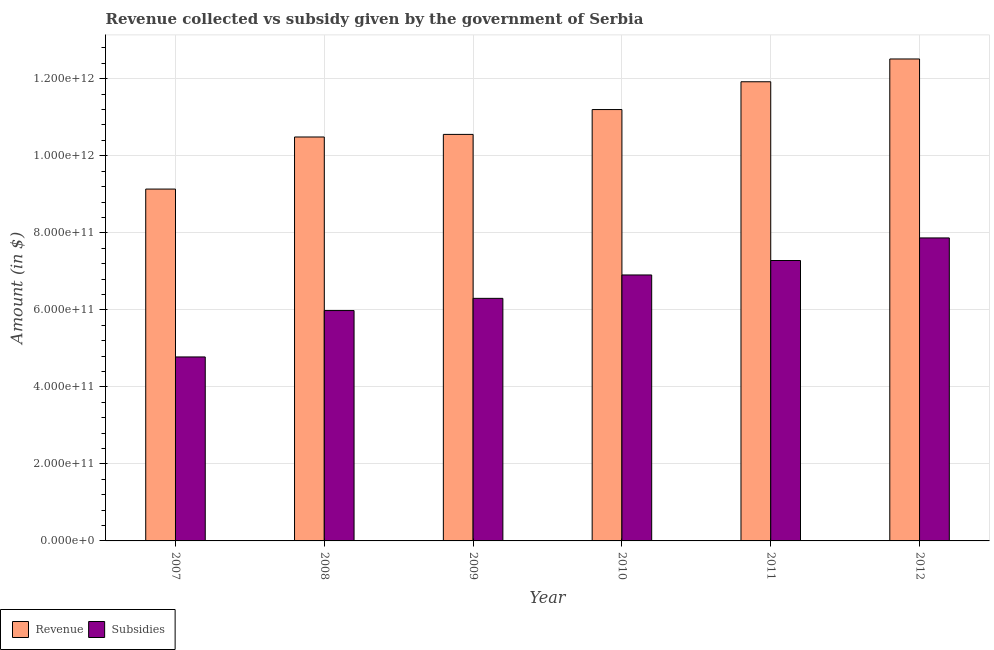How many different coloured bars are there?
Give a very brief answer. 2. How many groups of bars are there?
Your answer should be compact. 6. Are the number of bars per tick equal to the number of legend labels?
Offer a terse response. Yes. How many bars are there on the 2nd tick from the left?
Make the answer very short. 2. What is the label of the 4th group of bars from the left?
Give a very brief answer. 2010. What is the amount of subsidies given in 2007?
Your answer should be very brief. 4.78e+11. Across all years, what is the maximum amount of revenue collected?
Provide a succinct answer. 1.25e+12. Across all years, what is the minimum amount of subsidies given?
Keep it short and to the point. 4.78e+11. In which year was the amount of subsidies given minimum?
Offer a terse response. 2007. What is the total amount of subsidies given in the graph?
Give a very brief answer. 3.91e+12. What is the difference between the amount of revenue collected in 2008 and that in 2011?
Your answer should be very brief. -1.43e+11. What is the difference between the amount of revenue collected in 2008 and the amount of subsidies given in 2010?
Keep it short and to the point. -7.13e+1. What is the average amount of subsidies given per year?
Your response must be concise. 6.52e+11. In how many years, is the amount of subsidies given greater than 800000000000 $?
Offer a terse response. 0. What is the ratio of the amount of revenue collected in 2007 to that in 2009?
Offer a terse response. 0.87. Is the amount of revenue collected in 2007 less than that in 2008?
Offer a very short reply. Yes. Is the difference between the amount of revenue collected in 2010 and 2011 greater than the difference between the amount of subsidies given in 2010 and 2011?
Give a very brief answer. No. What is the difference between the highest and the second highest amount of revenue collected?
Make the answer very short. 5.92e+1. What is the difference between the highest and the lowest amount of revenue collected?
Make the answer very short. 3.38e+11. Is the sum of the amount of revenue collected in 2011 and 2012 greater than the maximum amount of subsidies given across all years?
Offer a terse response. Yes. What does the 1st bar from the left in 2008 represents?
Ensure brevity in your answer.  Revenue. What does the 1st bar from the right in 2008 represents?
Ensure brevity in your answer.  Subsidies. Are all the bars in the graph horizontal?
Give a very brief answer. No. What is the difference between two consecutive major ticks on the Y-axis?
Make the answer very short. 2.00e+11. Are the values on the major ticks of Y-axis written in scientific E-notation?
Provide a short and direct response. Yes. Does the graph contain any zero values?
Keep it short and to the point. No. Where does the legend appear in the graph?
Give a very brief answer. Bottom left. How many legend labels are there?
Make the answer very short. 2. How are the legend labels stacked?
Your answer should be very brief. Horizontal. What is the title of the graph?
Provide a succinct answer. Revenue collected vs subsidy given by the government of Serbia. What is the label or title of the X-axis?
Give a very brief answer. Year. What is the label or title of the Y-axis?
Provide a succinct answer. Amount (in $). What is the Amount (in $) in Revenue in 2007?
Offer a terse response. 9.14e+11. What is the Amount (in $) of Subsidies in 2007?
Make the answer very short. 4.78e+11. What is the Amount (in $) in Revenue in 2008?
Your response must be concise. 1.05e+12. What is the Amount (in $) of Subsidies in 2008?
Your answer should be very brief. 5.98e+11. What is the Amount (in $) of Revenue in 2009?
Offer a terse response. 1.06e+12. What is the Amount (in $) of Subsidies in 2009?
Offer a very short reply. 6.30e+11. What is the Amount (in $) of Revenue in 2010?
Your answer should be very brief. 1.12e+12. What is the Amount (in $) in Subsidies in 2010?
Your response must be concise. 6.91e+11. What is the Amount (in $) of Revenue in 2011?
Your answer should be compact. 1.19e+12. What is the Amount (in $) of Subsidies in 2011?
Your answer should be very brief. 7.28e+11. What is the Amount (in $) of Revenue in 2012?
Your response must be concise. 1.25e+12. What is the Amount (in $) of Subsidies in 2012?
Your response must be concise. 7.87e+11. Across all years, what is the maximum Amount (in $) of Revenue?
Your response must be concise. 1.25e+12. Across all years, what is the maximum Amount (in $) in Subsidies?
Your answer should be compact. 7.87e+11. Across all years, what is the minimum Amount (in $) in Revenue?
Your response must be concise. 9.14e+11. Across all years, what is the minimum Amount (in $) of Subsidies?
Your response must be concise. 4.78e+11. What is the total Amount (in $) of Revenue in the graph?
Provide a succinct answer. 6.58e+12. What is the total Amount (in $) in Subsidies in the graph?
Offer a very short reply. 3.91e+12. What is the difference between the Amount (in $) of Revenue in 2007 and that in 2008?
Ensure brevity in your answer.  -1.35e+11. What is the difference between the Amount (in $) of Subsidies in 2007 and that in 2008?
Ensure brevity in your answer.  -1.20e+11. What is the difference between the Amount (in $) in Revenue in 2007 and that in 2009?
Keep it short and to the point. -1.42e+11. What is the difference between the Amount (in $) in Subsidies in 2007 and that in 2009?
Make the answer very short. -1.52e+11. What is the difference between the Amount (in $) in Revenue in 2007 and that in 2010?
Give a very brief answer. -2.06e+11. What is the difference between the Amount (in $) in Subsidies in 2007 and that in 2010?
Offer a terse response. -2.13e+11. What is the difference between the Amount (in $) in Revenue in 2007 and that in 2011?
Provide a short and direct response. -2.79e+11. What is the difference between the Amount (in $) of Subsidies in 2007 and that in 2011?
Your answer should be compact. -2.50e+11. What is the difference between the Amount (in $) in Revenue in 2007 and that in 2012?
Offer a terse response. -3.38e+11. What is the difference between the Amount (in $) of Subsidies in 2007 and that in 2012?
Offer a very short reply. -3.09e+11. What is the difference between the Amount (in $) of Revenue in 2008 and that in 2009?
Make the answer very short. -6.74e+09. What is the difference between the Amount (in $) of Subsidies in 2008 and that in 2009?
Your response must be concise. -3.17e+1. What is the difference between the Amount (in $) of Revenue in 2008 and that in 2010?
Your answer should be compact. -7.13e+1. What is the difference between the Amount (in $) in Subsidies in 2008 and that in 2010?
Your answer should be compact. -9.24e+1. What is the difference between the Amount (in $) of Revenue in 2008 and that in 2011?
Provide a short and direct response. -1.43e+11. What is the difference between the Amount (in $) in Subsidies in 2008 and that in 2011?
Your answer should be very brief. -1.30e+11. What is the difference between the Amount (in $) of Revenue in 2008 and that in 2012?
Make the answer very short. -2.03e+11. What is the difference between the Amount (in $) of Subsidies in 2008 and that in 2012?
Keep it short and to the point. -1.89e+11. What is the difference between the Amount (in $) in Revenue in 2009 and that in 2010?
Your answer should be very brief. -6.45e+1. What is the difference between the Amount (in $) in Subsidies in 2009 and that in 2010?
Ensure brevity in your answer.  -6.07e+1. What is the difference between the Amount (in $) of Revenue in 2009 and that in 2011?
Make the answer very short. -1.37e+11. What is the difference between the Amount (in $) of Subsidies in 2009 and that in 2011?
Offer a terse response. -9.83e+1. What is the difference between the Amount (in $) of Revenue in 2009 and that in 2012?
Offer a terse response. -1.96e+11. What is the difference between the Amount (in $) in Subsidies in 2009 and that in 2012?
Your answer should be compact. -1.57e+11. What is the difference between the Amount (in $) in Revenue in 2010 and that in 2011?
Your response must be concise. -7.22e+1. What is the difference between the Amount (in $) of Subsidies in 2010 and that in 2011?
Ensure brevity in your answer.  -3.75e+1. What is the difference between the Amount (in $) of Revenue in 2010 and that in 2012?
Provide a short and direct response. -1.31e+11. What is the difference between the Amount (in $) in Subsidies in 2010 and that in 2012?
Your answer should be compact. -9.62e+1. What is the difference between the Amount (in $) of Revenue in 2011 and that in 2012?
Your answer should be compact. -5.92e+1. What is the difference between the Amount (in $) of Subsidies in 2011 and that in 2012?
Your response must be concise. -5.86e+1. What is the difference between the Amount (in $) of Revenue in 2007 and the Amount (in $) of Subsidies in 2008?
Provide a succinct answer. 3.15e+11. What is the difference between the Amount (in $) in Revenue in 2007 and the Amount (in $) in Subsidies in 2009?
Offer a terse response. 2.84e+11. What is the difference between the Amount (in $) of Revenue in 2007 and the Amount (in $) of Subsidies in 2010?
Offer a very short reply. 2.23e+11. What is the difference between the Amount (in $) in Revenue in 2007 and the Amount (in $) in Subsidies in 2011?
Ensure brevity in your answer.  1.86e+11. What is the difference between the Amount (in $) of Revenue in 2007 and the Amount (in $) of Subsidies in 2012?
Provide a succinct answer. 1.27e+11. What is the difference between the Amount (in $) in Revenue in 2008 and the Amount (in $) in Subsidies in 2009?
Offer a very short reply. 4.19e+11. What is the difference between the Amount (in $) in Revenue in 2008 and the Amount (in $) in Subsidies in 2010?
Make the answer very short. 3.58e+11. What is the difference between the Amount (in $) of Revenue in 2008 and the Amount (in $) of Subsidies in 2011?
Your response must be concise. 3.21e+11. What is the difference between the Amount (in $) in Revenue in 2008 and the Amount (in $) in Subsidies in 2012?
Provide a succinct answer. 2.62e+11. What is the difference between the Amount (in $) of Revenue in 2009 and the Amount (in $) of Subsidies in 2010?
Keep it short and to the point. 3.65e+11. What is the difference between the Amount (in $) in Revenue in 2009 and the Amount (in $) in Subsidies in 2011?
Give a very brief answer. 3.27e+11. What is the difference between the Amount (in $) in Revenue in 2009 and the Amount (in $) in Subsidies in 2012?
Your answer should be compact. 2.69e+11. What is the difference between the Amount (in $) of Revenue in 2010 and the Amount (in $) of Subsidies in 2011?
Keep it short and to the point. 3.92e+11. What is the difference between the Amount (in $) of Revenue in 2010 and the Amount (in $) of Subsidies in 2012?
Offer a terse response. 3.33e+11. What is the difference between the Amount (in $) in Revenue in 2011 and the Amount (in $) in Subsidies in 2012?
Give a very brief answer. 4.06e+11. What is the average Amount (in $) of Revenue per year?
Provide a short and direct response. 1.10e+12. What is the average Amount (in $) of Subsidies per year?
Your response must be concise. 6.52e+11. In the year 2007, what is the difference between the Amount (in $) in Revenue and Amount (in $) in Subsidies?
Offer a very short reply. 4.36e+11. In the year 2008, what is the difference between the Amount (in $) of Revenue and Amount (in $) of Subsidies?
Offer a terse response. 4.51e+11. In the year 2009, what is the difference between the Amount (in $) in Revenue and Amount (in $) in Subsidies?
Give a very brief answer. 4.26e+11. In the year 2010, what is the difference between the Amount (in $) in Revenue and Amount (in $) in Subsidies?
Offer a terse response. 4.29e+11. In the year 2011, what is the difference between the Amount (in $) in Revenue and Amount (in $) in Subsidies?
Provide a short and direct response. 4.64e+11. In the year 2012, what is the difference between the Amount (in $) in Revenue and Amount (in $) in Subsidies?
Provide a succinct answer. 4.65e+11. What is the ratio of the Amount (in $) of Revenue in 2007 to that in 2008?
Provide a short and direct response. 0.87. What is the ratio of the Amount (in $) of Subsidies in 2007 to that in 2008?
Keep it short and to the point. 0.8. What is the ratio of the Amount (in $) in Revenue in 2007 to that in 2009?
Offer a terse response. 0.87. What is the ratio of the Amount (in $) of Subsidies in 2007 to that in 2009?
Offer a terse response. 0.76. What is the ratio of the Amount (in $) of Revenue in 2007 to that in 2010?
Your answer should be compact. 0.82. What is the ratio of the Amount (in $) of Subsidies in 2007 to that in 2010?
Keep it short and to the point. 0.69. What is the ratio of the Amount (in $) of Revenue in 2007 to that in 2011?
Your answer should be very brief. 0.77. What is the ratio of the Amount (in $) in Subsidies in 2007 to that in 2011?
Give a very brief answer. 0.66. What is the ratio of the Amount (in $) of Revenue in 2007 to that in 2012?
Offer a very short reply. 0.73. What is the ratio of the Amount (in $) in Subsidies in 2007 to that in 2012?
Give a very brief answer. 0.61. What is the ratio of the Amount (in $) in Revenue in 2008 to that in 2009?
Your answer should be very brief. 0.99. What is the ratio of the Amount (in $) in Subsidies in 2008 to that in 2009?
Provide a succinct answer. 0.95. What is the ratio of the Amount (in $) of Revenue in 2008 to that in 2010?
Provide a short and direct response. 0.94. What is the ratio of the Amount (in $) in Subsidies in 2008 to that in 2010?
Provide a short and direct response. 0.87. What is the ratio of the Amount (in $) in Revenue in 2008 to that in 2011?
Provide a succinct answer. 0.88. What is the ratio of the Amount (in $) in Subsidies in 2008 to that in 2011?
Make the answer very short. 0.82. What is the ratio of the Amount (in $) of Revenue in 2008 to that in 2012?
Provide a short and direct response. 0.84. What is the ratio of the Amount (in $) in Subsidies in 2008 to that in 2012?
Make the answer very short. 0.76. What is the ratio of the Amount (in $) in Revenue in 2009 to that in 2010?
Ensure brevity in your answer.  0.94. What is the ratio of the Amount (in $) in Subsidies in 2009 to that in 2010?
Ensure brevity in your answer.  0.91. What is the ratio of the Amount (in $) of Revenue in 2009 to that in 2011?
Offer a very short reply. 0.89. What is the ratio of the Amount (in $) of Subsidies in 2009 to that in 2011?
Provide a short and direct response. 0.86. What is the ratio of the Amount (in $) of Revenue in 2009 to that in 2012?
Give a very brief answer. 0.84. What is the ratio of the Amount (in $) in Subsidies in 2009 to that in 2012?
Provide a succinct answer. 0.8. What is the ratio of the Amount (in $) in Revenue in 2010 to that in 2011?
Give a very brief answer. 0.94. What is the ratio of the Amount (in $) in Subsidies in 2010 to that in 2011?
Your answer should be very brief. 0.95. What is the ratio of the Amount (in $) in Revenue in 2010 to that in 2012?
Offer a very short reply. 0.9. What is the ratio of the Amount (in $) in Subsidies in 2010 to that in 2012?
Offer a very short reply. 0.88. What is the ratio of the Amount (in $) in Revenue in 2011 to that in 2012?
Offer a very short reply. 0.95. What is the ratio of the Amount (in $) in Subsidies in 2011 to that in 2012?
Give a very brief answer. 0.93. What is the difference between the highest and the second highest Amount (in $) of Revenue?
Offer a very short reply. 5.92e+1. What is the difference between the highest and the second highest Amount (in $) in Subsidies?
Your answer should be very brief. 5.86e+1. What is the difference between the highest and the lowest Amount (in $) in Revenue?
Give a very brief answer. 3.38e+11. What is the difference between the highest and the lowest Amount (in $) of Subsidies?
Offer a very short reply. 3.09e+11. 